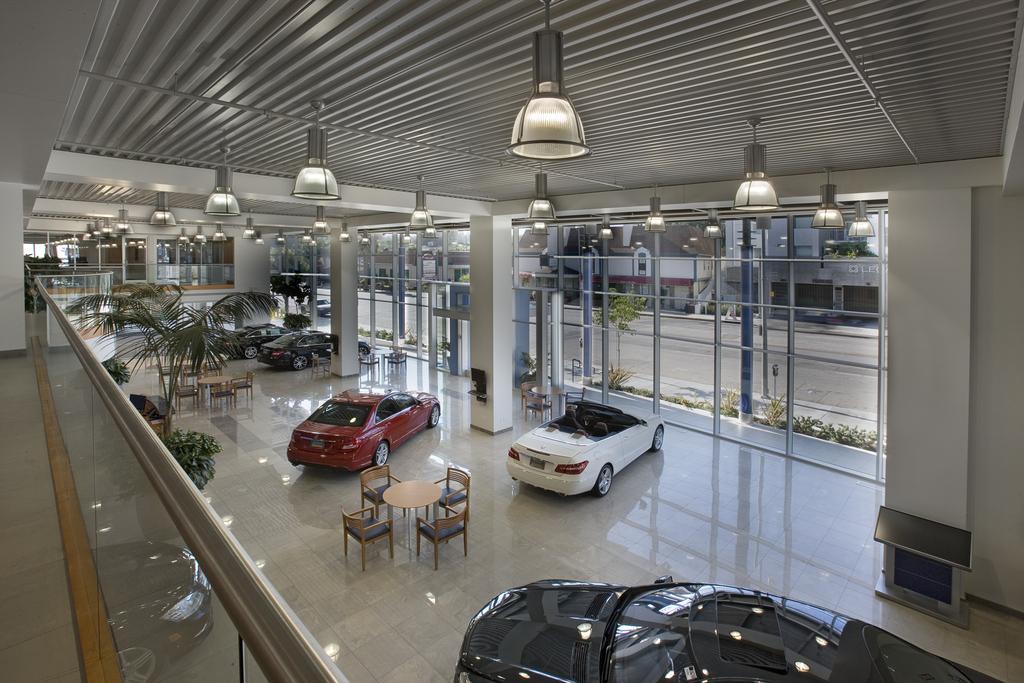Could you give a brief overview of what you see in this image? In this picture we can observe some cars. We can observe red, white and black color cars. There is a table around which there are some chairs. We can observe some plants and a tree here. On the left side there is a glass railing. We can observe some lights hanging from the ceiling. In the background there is a road and we can observe some buildings. 